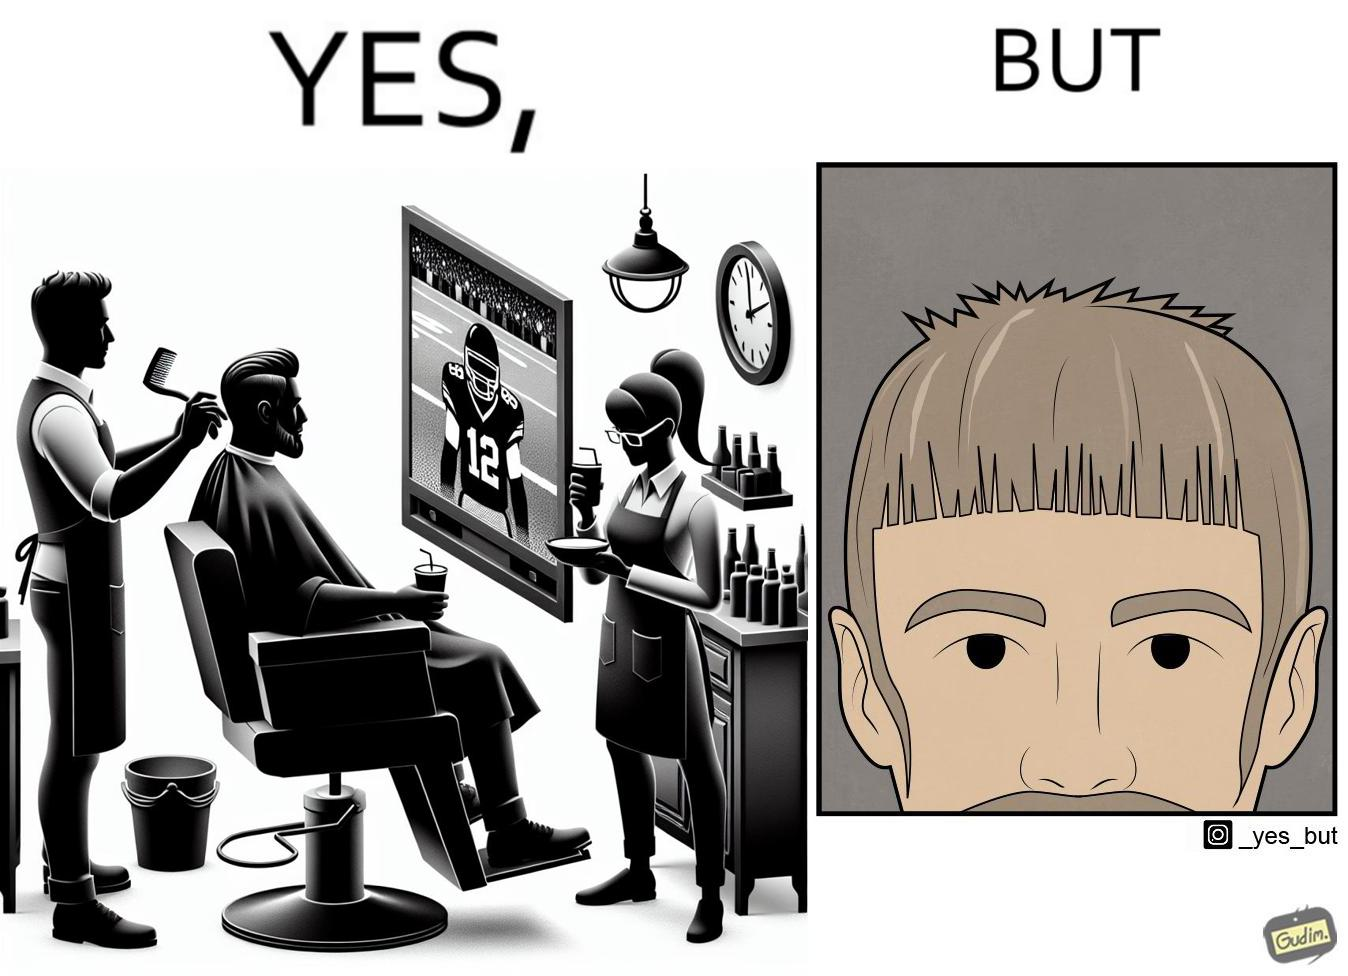Would you classify this image as satirical? Yes, this image is satirical. 